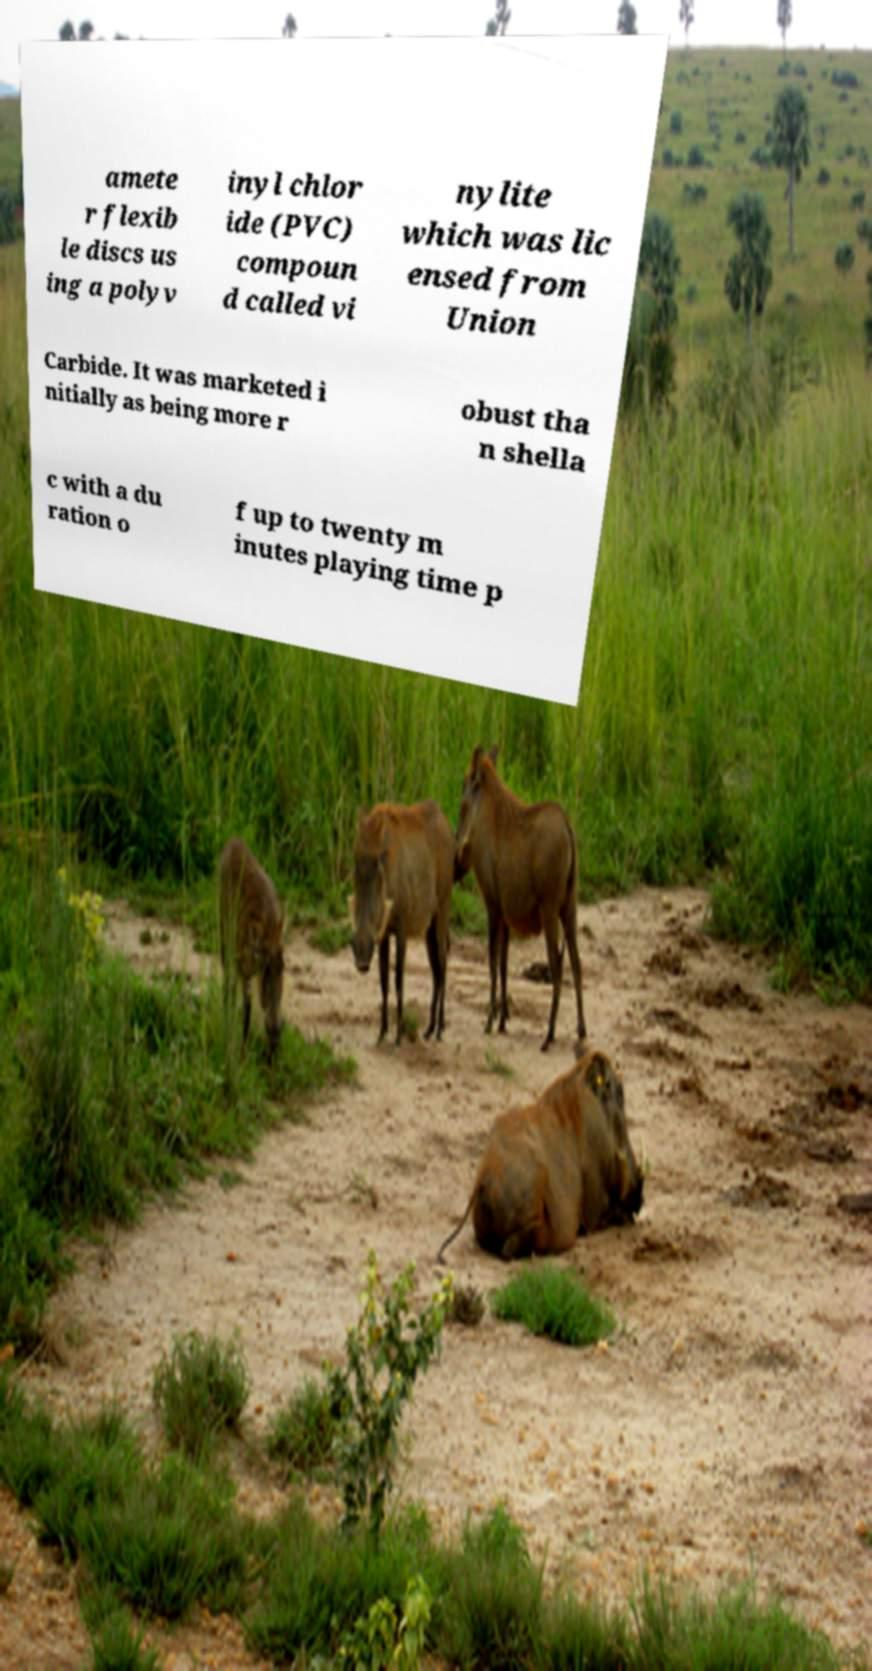Could you extract and type out the text from this image? amete r flexib le discs us ing a polyv inyl chlor ide (PVC) compoun d called vi nylite which was lic ensed from Union Carbide. It was marketed i nitially as being more r obust tha n shella c with a du ration o f up to twenty m inutes playing time p 